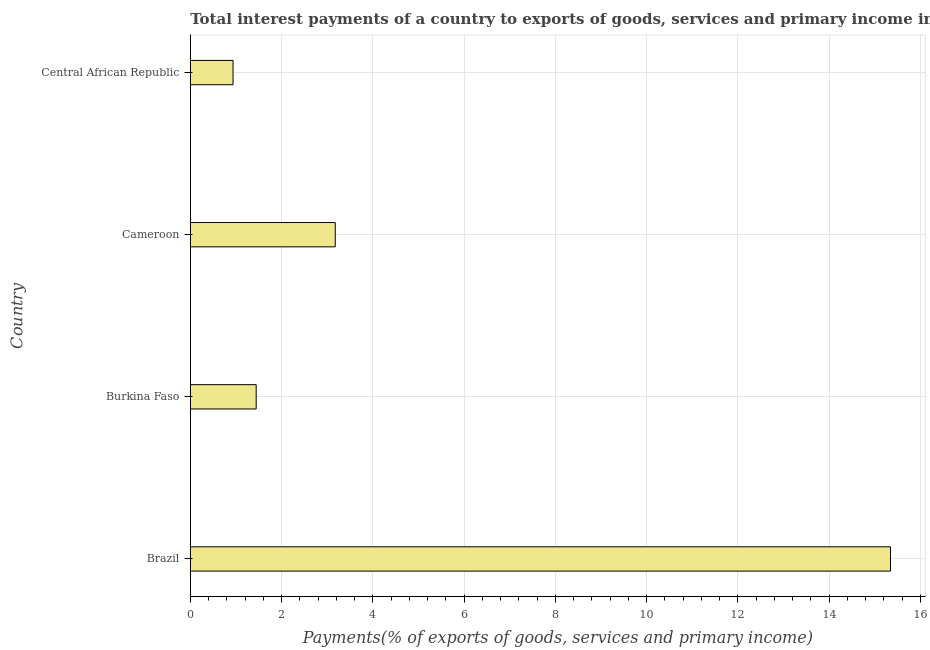What is the title of the graph?
Provide a short and direct response. Total interest payments of a country to exports of goods, services and primary income in 1977. What is the label or title of the X-axis?
Your answer should be compact. Payments(% of exports of goods, services and primary income). What is the label or title of the Y-axis?
Provide a succinct answer. Country. What is the total interest payments on external debt in Central African Republic?
Provide a short and direct response. 0.94. Across all countries, what is the maximum total interest payments on external debt?
Your answer should be compact. 15.35. Across all countries, what is the minimum total interest payments on external debt?
Make the answer very short. 0.94. In which country was the total interest payments on external debt minimum?
Make the answer very short. Central African Republic. What is the sum of the total interest payments on external debt?
Provide a succinct answer. 20.91. What is the difference between the total interest payments on external debt in Brazil and Central African Republic?
Give a very brief answer. 14.41. What is the average total interest payments on external debt per country?
Your answer should be compact. 5.23. What is the median total interest payments on external debt?
Offer a very short reply. 2.31. What is the ratio of the total interest payments on external debt in Burkina Faso to that in Central African Republic?
Your answer should be compact. 1.54. Is the total interest payments on external debt in Burkina Faso less than that in Central African Republic?
Ensure brevity in your answer.  No. Is the difference between the total interest payments on external debt in Cameroon and Central African Republic greater than the difference between any two countries?
Provide a short and direct response. No. What is the difference between the highest and the second highest total interest payments on external debt?
Ensure brevity in your answer.  12.17. Is the sum of the total interest payments on external debt in Brazil and Central African Republic greater than the maximum total interest payments on external debt across all countries?
Keep it short and to the point. Yes. What is the difference between the highest and the lowest total interest payments on external debt?
Give a very brief answer. 14.41. In how many countries, is the total interest payments on external debt greater than the average total interest payments on external debt taken over all countries?
Provide a succinct answer. 1. How many bars are there?
Keep it short and to the point. 4. Are all the bars in the graph horizontal?
Provide a short and direct response. Yes. Are the values on the major ticks of X-axis written in scientific E-notation?
Make the answer very short. No. What is the Payments(% of exports of goods, services and primary income) of Brazil?
Provide a succinct answer. 15.35. What is the Payments(% of exports of goods, services and primary income) in Burkina Faso?
Your answer should be very brief. 1.44. What is the Payments(% of exports of goods, services and primary income) in Cameroon?
Your answer should be very brief. 3.18. What is the Payments(% of exports of goods, services and primary income) in Central African Republic?
Provide a succinct answer. 0.94. What is the difference between the Payments(% of exports of goods, services and primary income) in Brazil and Burkina Faso?
Keep it short and to the point. 13.9. What is the difference between the Payments(% of exports of goods, services and primary income) in Brazil and Cameroon?
Your answer should be compact. 12.17. What is the difference between the Payments(% of exports of goods, services and primary income) in Brazil and Central African Republic?
Your answer should be compact. 14.41. What is the difference between the Payments(% of exports of goods, services and primary income) in Burkina Faso and Cameroon?
Give a very brief answer. -1.73. What is the difference between the Payments(% of exports of goods, services and primary income) in Burkina Faso and Central African Republic?
Your answer should be compact. 0.51. What is the difference between the Payments(% of exports of goods, services and primary income) in Cameroon and Central African Republic?
Your answer should be very brief. 2.24. What is the ratio of the Payments(% of exports of goods, services and primary income) in Brazil to that in Burkina Faso?
Provide a short and direct response. 10.62. What is the ratio of the Payments(% of exports of goods, services and primary income) in Brazil to that in Cameroon?
Offer a terse response. 4.83. What is the ratio of the Payments(% of exports of goods, services and primary income) in Brazil to that in Central African Republic?
Offer a very short reply. 16.38. What is the ratio of the Payments(% of exports of goods, services and primary income) in Burkina Faso to that in Cameroon?
Offer a very short reply. 0.46. What is the ratio of the Payments(% of exports of goods, services and primary income) in Burkina Faso to that in Central African Republic?
Your answer should be compact. 1.54. What is the ratio of the Payments(% of exports of goods, services and primary income) in Cameroon to that in Central African Republic?
Give a very brief answer. 3.39. 